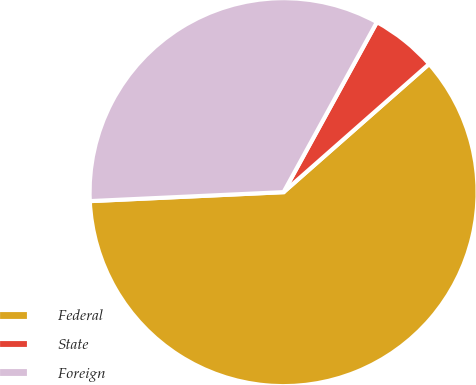<chart> <loc_0><loc_0><loc_500><loc_500><pie_chart><fcel>Federal<fcel>State<fcel>Foreign<nl><fcel>60.76%<fcel>5.52%<fcel>33.73%<nl></chart> 